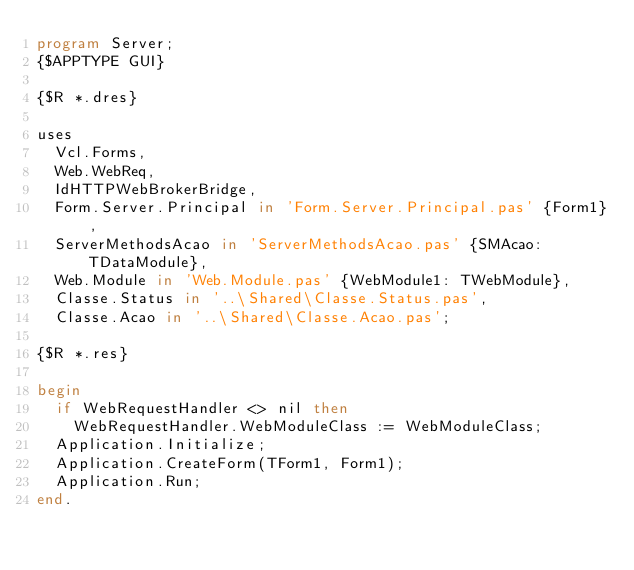<code> <loc_0><loc_0><loc_500><loc_500><_Pascal_>program Server;
{$APPTYPE GUI}

{$R *.dres}

uses
  Vcl.Forms,
  Web.WebReq,
  IdHTTPWebBrokerBridge,
  Form.Server.Principal in 'Form.Server.Principal.pas' {Form1},
  ServerMethodsAcao in 'ServerMethodsAcao.pas' {SMAcao: TDataModule},
  Web.Module in 'Web.Module.pas' {WebModule1: TWebModule},
  Classe.Status in '..\Shared\Classe.Status.pas',
  Classe.Acao in '..\Shared\Classe.Acao.pas';

{$R *.res}

begin
  if WebRequestHandler <> nil then
    WebRequestHandler.WebModuleClass := WebModuleClass;
  Application.Initialize;
  Application.CreateForm(TForm1, Form1);
  Application.Run;
end.
</code> 